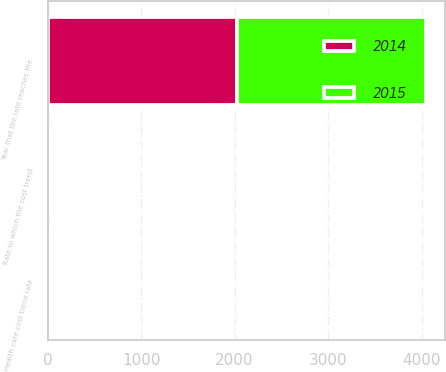<chart> <loc_0><loc_0><loc_500><loc_500><stacked_bar_chart><ecel><fcel>Health care cost trend rate<fcel>Rate to which the cost trend<fcel>Year that the rate reaches the<nl><fcel>2015<fcel>5.21<fcel>4.56<fcel>2024<nl><fcel>2014<fcel>5.25<fcel>4.55<fcel>2023<nl></chart> 